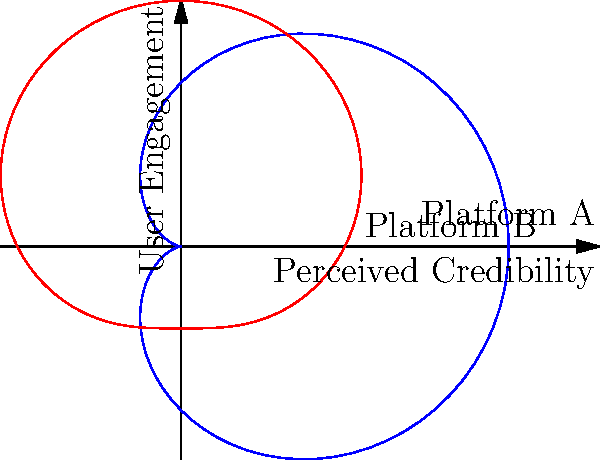Analyze the polar graph representing the correlation between user engagement and perceived credibility of information on two social media platforms. Which platform demonstrates a stronger positive correlation between these variables, and what epistemological implications might this have for our perception of truth in the digital age? To answer this question, let's analyze the polar graphs step-by-step:

1. The blue curve (Platform A) is represented by the polar equation $r = 2 + 2\cos(\theta)$, while the red curve (Platform B) is represented by $r = 2 + \sin(\theta)$.

2. In polar coordinates, $r$ represents the distance from the origin, which in this case corresponds to the strength of the correlation between user engagement and perceived credibility.

3. For Platform A:
   - The maximum $r$ value occurs when $\cos(\theta) = 1$, giving $r_{max} = 4$.
   - The minimum $r$ value occurs when $\cos(\theta) = -1$, giving $r_{min} = 0$.

4. For Platform B:
   - The maximum $r$ value occurs when $\sin(\theta) = 1$, giving $r_{max} = 3$.
   - The minimum $r$ value occurs when $\sin(\theta) = -1$, giving $r_{min} = 1$.

5. Platform A shows a wider range of correlation (from 0 to 4) compared to Platform B (from 1 to 3), indicating a stronger overall correlation.

6. The shape of Platform A's curve (cardioid) shows a more pronounced positive correlation in one direction, while Platform B's curve (limacon) shows a more balanced correlation.

Epistemological implications:

1. The stronger correlation on Platform A suggests that user engagement has a more significant impact on perceived credibility, which could lead to a self-reinforcing cycle of popularity-based "truth."

2. This phenomenon might contribute to the formation of echo chambers and filter bubbles, where popular information is perceived as more credible regardless of its factual accuracy.

3. The discrepancy between the two platforms highlights the need for critical evaluation of information sources and the recognition that different social media environments may shape our perception of truth differently.

4. This analysis underscores the importance of developing new epistemological frameworks that account for the role of social media algorithms and user behavior in shaping our understanding of knowledge and truth in the digital age.
Answer: Platform A; reinforces popularity-based "truth" perception. 